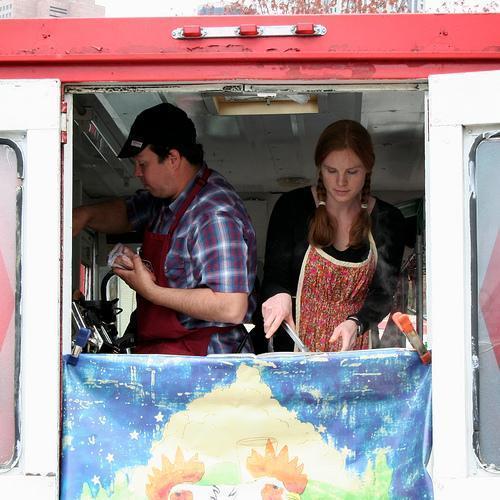How many people can you see?
Give a very brief answer. 2. How many buses are in the picture?
Give a very brief answer. 0. 